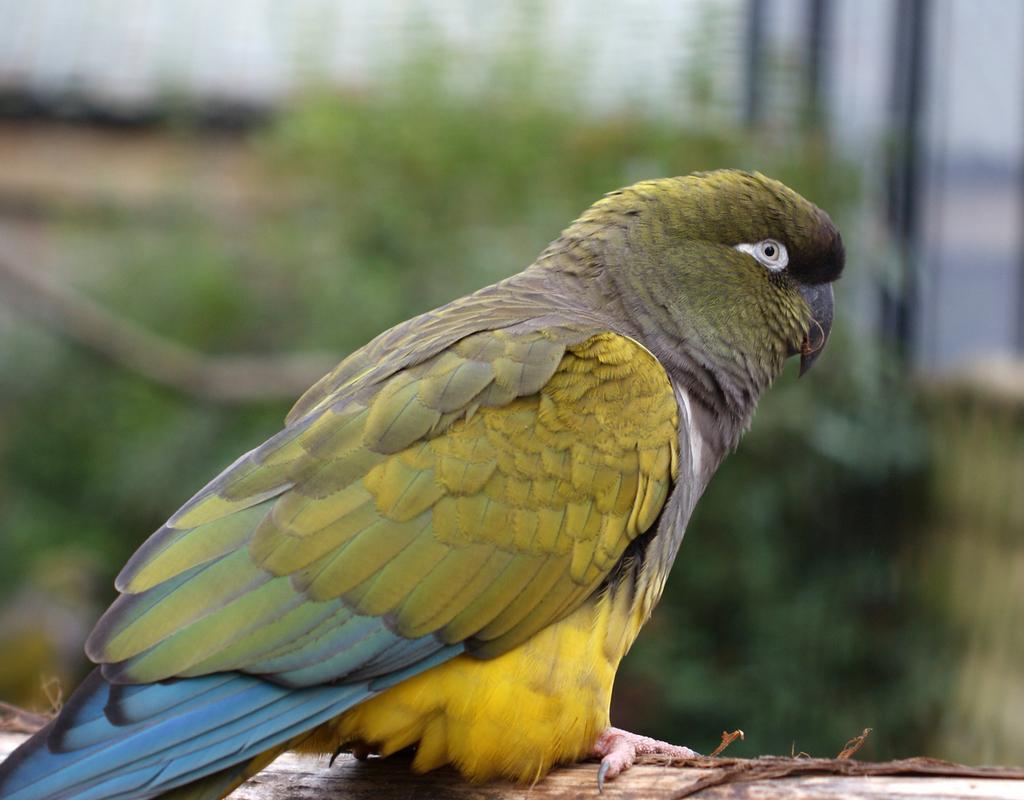Could you give a brief overview of what you see in this image? In this image there is a parrot sitting on the stem. In the background there is a plant. 